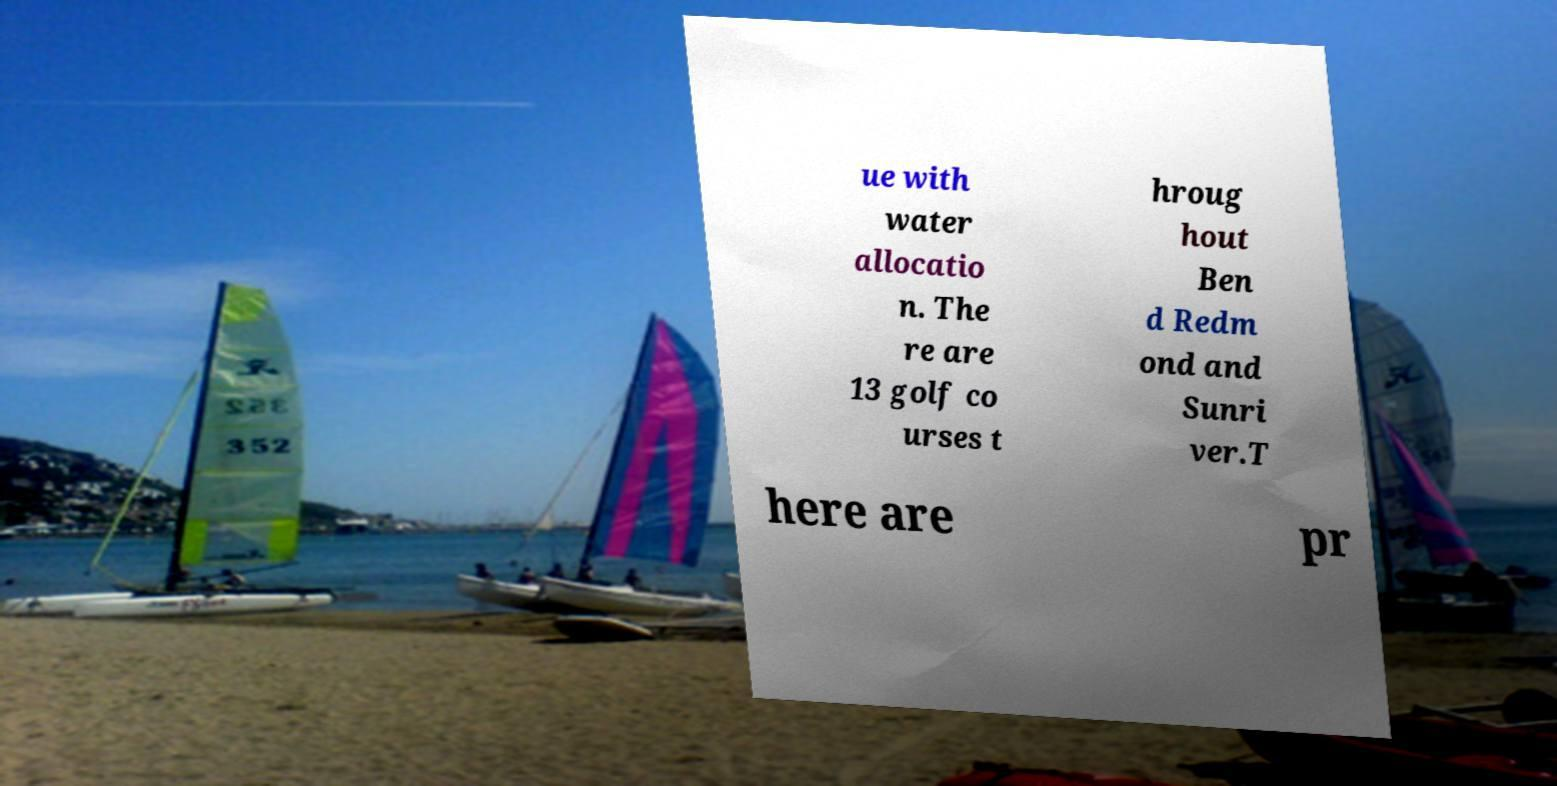I need the written content from this picture converted into text. Can you do that? ue with water allocatio n. The re are 13 golf co urses t hroug hout Ben d Redm ond and Sunri ver.T here are pr 